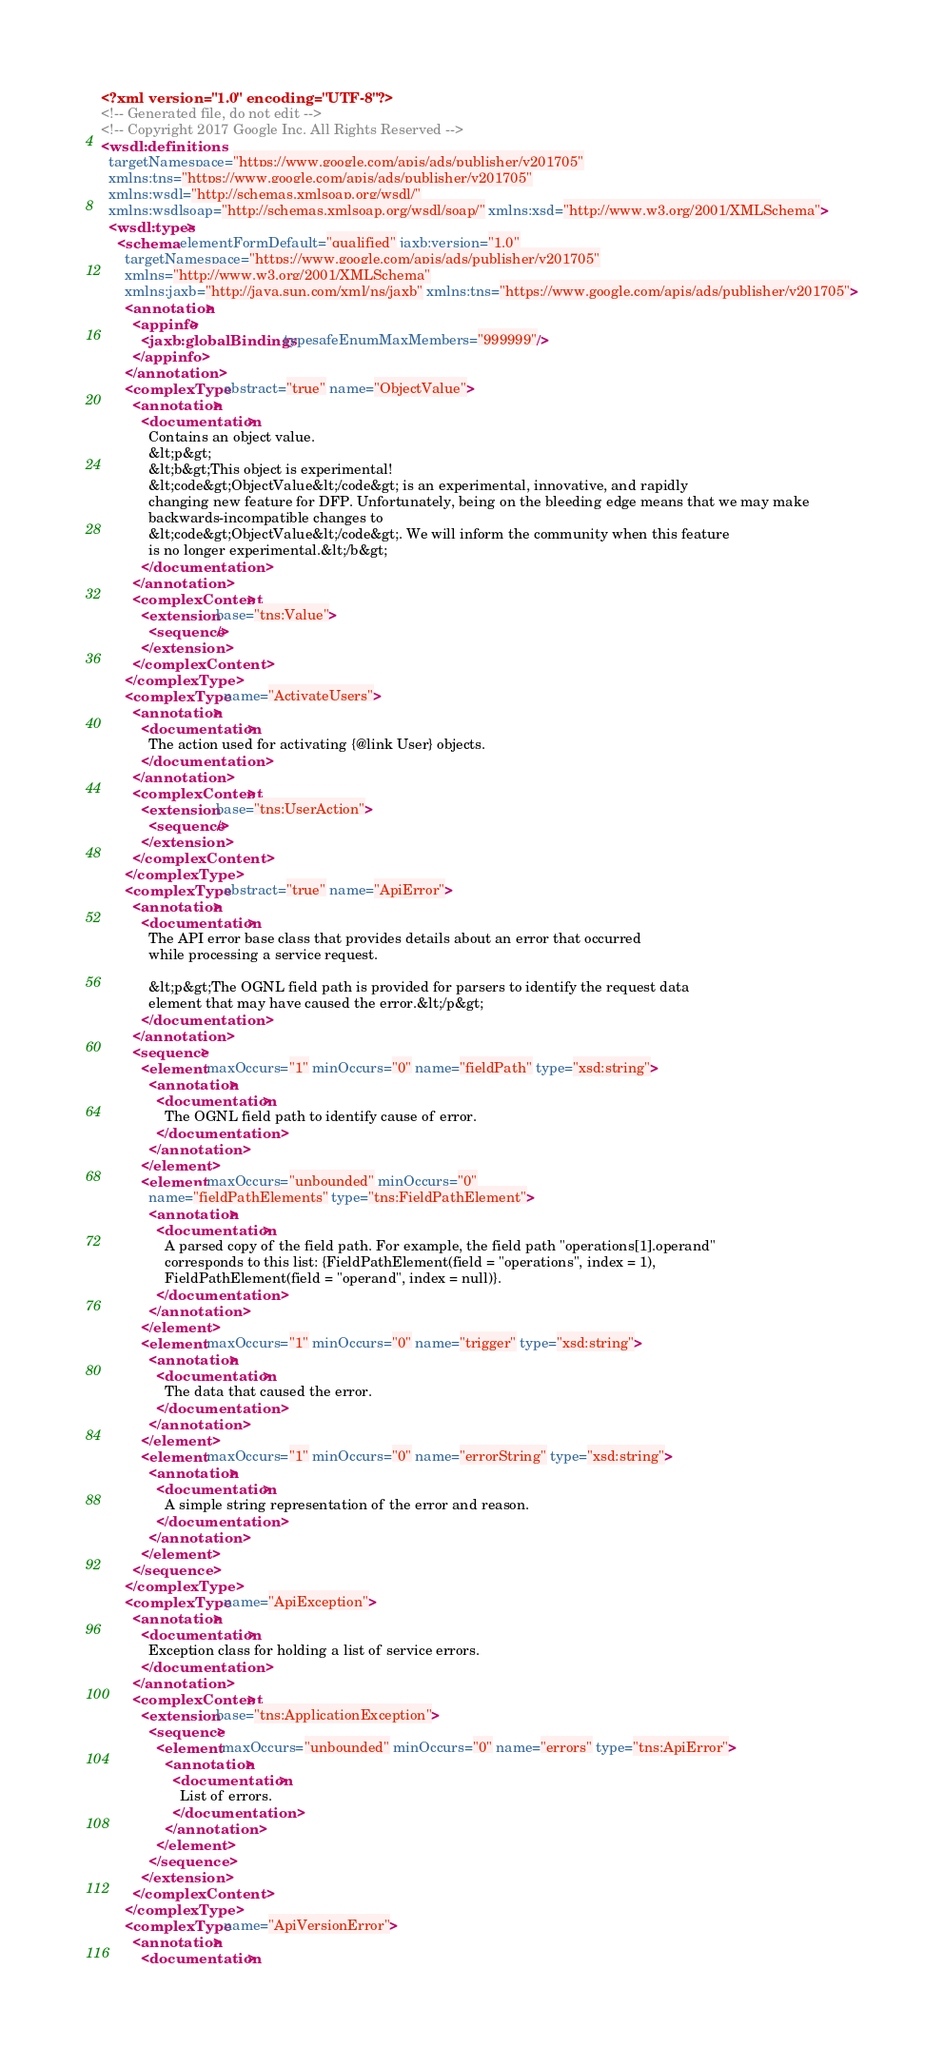<code> <loc_0><loc_0><loc_500><loc_500><_XML_><?xml version="1.0" encoding="UTF-8"?>
<!-- Generated file, do not edit -->
<!-- Copyright 2017 Google Inc. All Rights Reserved -->
<wsdl:definitions
  targetNamespace="https://www.google.com/apis/ads/publisher/v201705"
  xmlns:tns="https://www.google.com/apis/ads/publisher/v201705"
  xmlns:wsdl="http://schemas.xmlsoap.org/wsdl/"
  xmlns:wsdlsoap="http://schemas.xmlsoap.org/wsdl/soap/" xmlns:xsd="http://www.w3.org/2001/XMLSchema">
  <wsdl:types>
    <schema elementFormDefault="qualified" jaxb:version="1.0"
      targetNamespace="https://www.google.com/apis/ads/publisher/v201705"
      xmlns="http://www.w3.org/2001/XMLSchema"
      xmlns:jaxb="http://java.sun.com/xml/ns/jaxb" xmlns:tns="https://www.google.com/apis/ads/publisher/v201705">
      <annotation>
        <appinfo>
          <jaxb:globalBindings typesafeEnumMaxMembers="999999"/>
        </appinfo>
      </annotation>
      <complexType abstract="true" name="ObjectValue">
        <annotation>
          <documentation>
            Contains an object value.
            &lt;p&gt;
            &lt;b&gt;This object is experimental!
            &lt;code&gt;ObjectValue&lt;/code&gt; is an experimental, innovative, and rapidly
            changing new feature for DFP. Unfortunately, being on the bleeding edge means that we may make
            backwards-incompatible changes to
            &lt;code&gt;ObjectValue&lt;/code&gt;. We will inform the community when this feature
            is no longer experimental.&lt;/b&gt;
          </documentation>
        </annotation>
        <complexContent>
          <extension base="tns:Value">
            <sequence/>
          </extension>
        </complexContent>
      </complexType>
      <complexType name="ActivateUsers">
        <annotation>
          <documentation>
            The action used for activating {@link User} objects.
          </documentation>
        </annotation>
        <complexContent>
          <extension base="tns:UserAction">
            <sequence/>
          </extension>
        </complexContent>
      </complexType>
      <complexType abstract="true" name="ApiError">
        <annotation>
          <documentation>
            The API error base class that provides details about an error that occurred
            while processing a service request.
            
            &lt;p&gt;The OGNL field path is provided for parsers to identify the request data
            element that may have caused the error.&lt;/p&gt;
          </documentation>
        </annotation>
        <sequence>
          <element maxOccurs="1" minOccurs="0" name="fieldPath" type="xsd:string">
            <annotation>
              <documentation>
                The OGNL field path to identify cause of error.
              </documentation>
            </annotation>
          </element>
          <element maxOccurs="unbounded" minOccurs="0"
            name="fieldPathElements" type="tns:FieldPathElement">
            <annotation>
              <documentation>
                A parsed copy of the field path. For example, the field path "operations[1].operand"
                corresponds to this list: {FieldPathElement(field = "operations", index = 1),
                FieldPathElement(field = "operand", index = null)}.
              </documentation>
            </annotation>
          </element>
          <element maxOccurs="1" minOccurs="0" name="trigger" type="xsd:string">
            <annotation>
              <documentation>
                The data that caused the error.
              </documentation>
            </annotation>
          </element>
          <element maxOccurs="1" minOccurs="0" name="errorString" type="xsd:string">
            <annotation>
              <documentation>
                A simple string representation of the error and reason.
              </documentation>
            </annotation>
          </element>
        </sequence>
      </complexType>
      <complexType name="ApiException">
        <annotation>
          <documentation>
            Exception class for holding a list of service errors.
          </documentation>
        </annotation>
        <complexContent>
          <extension base="tns:ApplicationException">
            <sequence>
              <element maxOccurs="unbounded" minOccurs="0" name="errors" type="tns:ApiError">
                <annotation>
                  <documentation>
                    List of errors.
                  </documentation>
                </annotation>
              </element>
            </sequence>
          </extension>
        </complexContent>
      </complexType>
      <complexType name="ApiVersionError">
        <annotation>
          <documentation></code> 